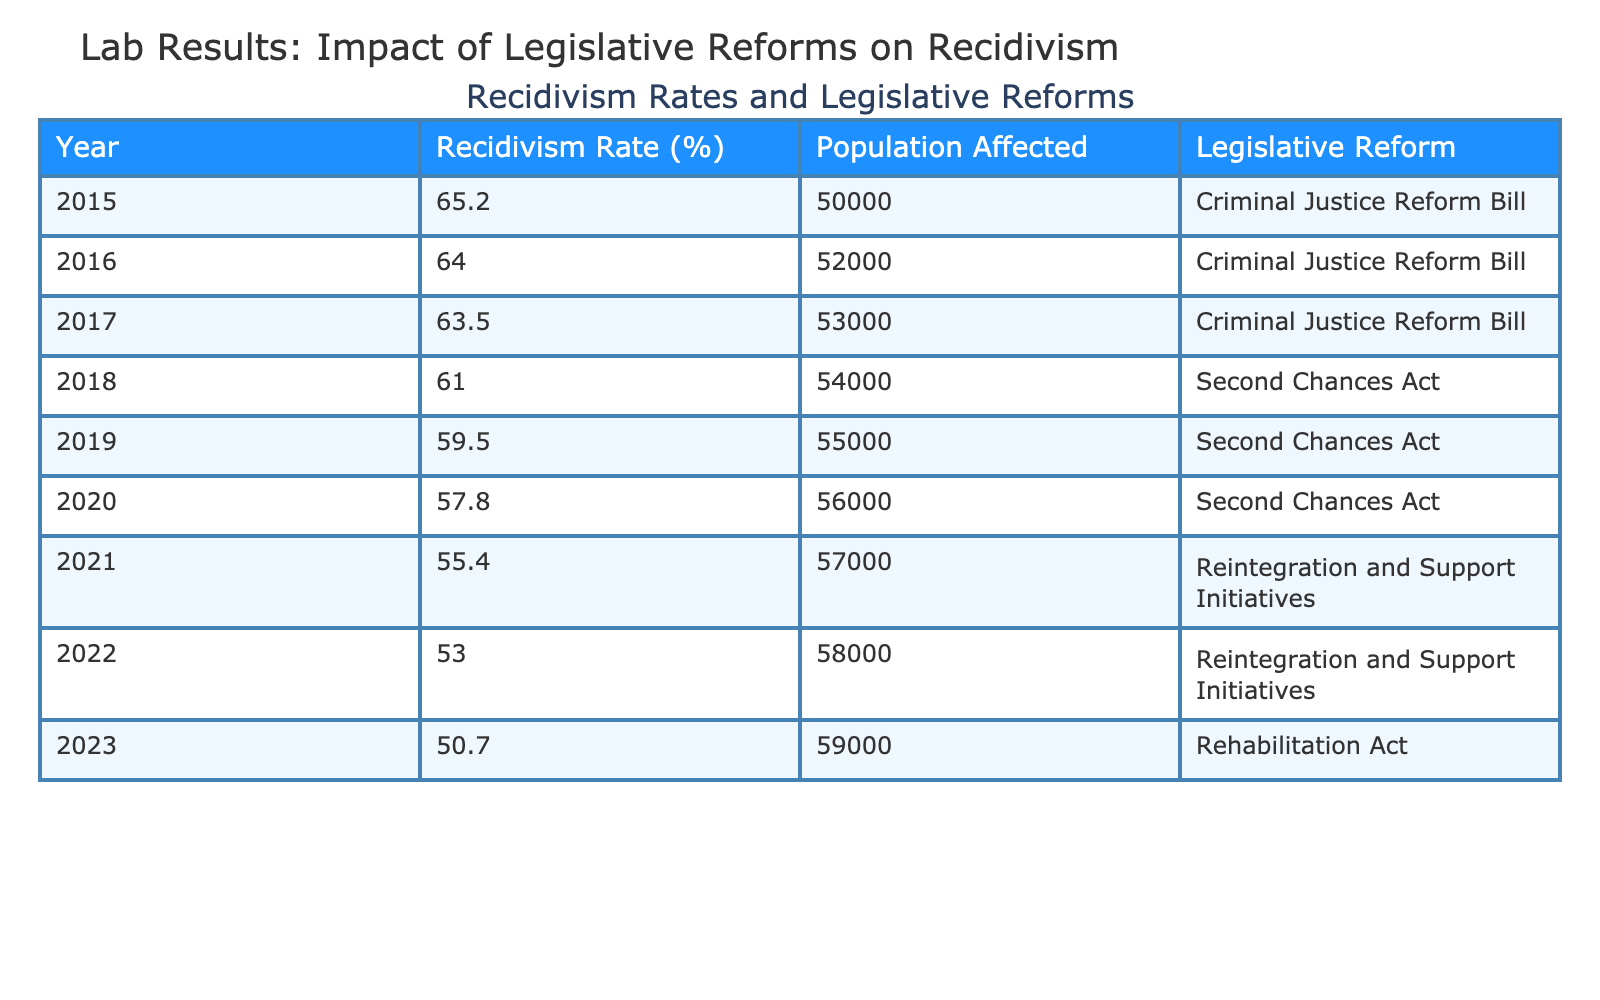What was the recidivism rate in 2015? According to the table, the recidivism rate for the year 2015 is listed directly in the first row of the "Recidivism Rate (%)" column, which shows a rate of 65.2%.
Answer: 65.2% Which year had the lowest recidivism rate? Looking through the "Recidivism Rate (%)" column from the years listed in the table, the year 2023 has the lowest rate of 50.7%.
Answer: 2023 What was the population affected in 2020? The table shows the population affected in 2020 in the "Population Affected" column, which is directly indicated as 56,000 for that year.
Answer: 56000 How much did the recidivism rate decrease from 2015 to 2023? To find this decrease, subtract the recidivism rate of 2023 (50.7%) from 2015 (65.2%). The calculation is 65.2 - 50.7 = 14.5. Therefore, the recidivism rate decreased by 14.5%.
Answer: 14.5% Did the Second Chances Act influence the recidivism rates positively? The recidivism rates decreased each year during the implementation of the Second Chances Act from 2018 to 2020, starting from 61.0% in 2018 down to 57.8% in 2020. Therefore, it is reasonable to conclude that the act had a positive influence on reducing recidivism rates.
Answer: Yes What is the average recidivism rate from 2016 to 2021? To calculate the average, first, find the rates from 2016 to 2021: 64.0, 63.5, 61.0, 59.5, and 55.4. Adding them together gives a total of 63.4. There are 5 data points, so the average is 63.4 / 5 = 63.4%.
Answer: 63.4% Did any year have a population affected of more than 55,000? By reviewing the "Population Affected" column, we can see that the numbers for years 2016, 2017, 2018, 2019, 2020, 2021, 2022, and 2023 are all above 55,000. Thus, the answer is affirmative for multiple years.
Answer: Yes How does the average recidivism rate between 2015 and 2017 compare to the one from 2021 to 2023? First, calculate the average recidivism rate from 2015 to 2017: (65.2 + 64.0 + 63.5) / 3 = 64.23%. Next, calculate the average from 2021 to 2023: (55.4 + 53.0 + 50.7) / 3 = 53.33%. Comparing these averages shows that the rate decreased from 64.23% to 53.33%.
Answer: Decreased What legislative reform was associated with the lowest recidivism rate? Referring to the table, the year with the lowest recidivism rate (2023) corresponds to the "Rehabilitation Act". Thus, it is this reform that is associated with the lowest recidivism rate recorded.
Answer: Rehabilitation Act 